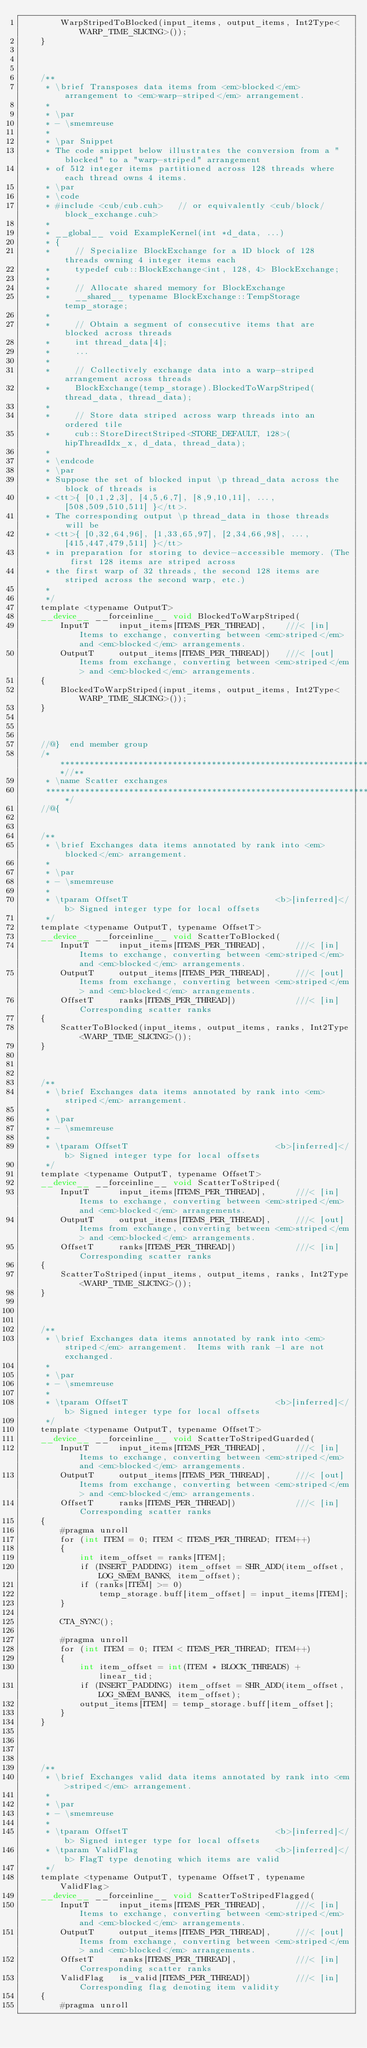Convert code to text. <code><loc_0><loc_0><loc_500><loc_500><_Cuda_>        WarpStripedToBlocked(input_items, output_items, Int2Type<WARP_TIME_SLICING>());
    }



    /**
     * \brief Transposes data items from <em>blocked</em> arrangement to <em>warp-striped</em> arrangement.
     *
     * \par
     * - \smemreuse
     *
     * \par Snippet
     * The code snippet below illustrates the conversion from a "blocked" to a "warp-striped" arrangement
     * of 512 integer items partitioned across 128 threads where each thread owns 4 items.
     * \par
     * \code
     * #include <cub/cub.cuh>   // or equivalently <cub/block/block_exchange.cuh>
     *
     * __global__ void ExampleKernel(int *d_data, ...)
     * {
     *     // Specialize BlockExchange for a 1D block of 128 threads owning 4 integer items each
     *     typedef cub::BlockExchange<int, 128, 4> BlockExchange;
     *
     *     // Allocate shared memory for BlockExchange
     *     __shared__ typename BlockExchange::TempStorage temp_storage;
     *
     *     // Obtain a segment of consecutive items that are blocked across threads
     *     int thread_data[4];
     *     ...
     *
     *     // Collectively exchange data into a warp-striped arrangement across threads
     *     BlockExchange(temp_storage).BlockedToWarpStriped(thread_data, thread_data);
     *
     *     // Store data striped across warp threads into an ordered tile
     *     cub::StoreDirectStriped<STORE_DEFAULT, 128>(hipThreadIdx_x, d_data, thread_data);
     *
     * \endcode
     * \par
     * Suppose the set of blocked input \p thread_data across the block of threads is
     * <tt>{ [0,1,2,3], [4,5,6,7], [8,9,10,11], ..., [508,509,510,511] }</tt>.
     * The corresponding output \p thread_data in those threads will be
     * <tt>{ [0,32,64,96], [1,33,65,97], [2,34,66,98], ..., [415,447,479,511] }</tt>
     * in preparation for storing to device-accessible memory. (The first 128 items are striped across
     * the first warp of 32 threads, the second 128 items are striped across the second warp, etc.)
     *
     */
    template <typename OutputT>
    __device__ __forceinline__ void BlockedToWarpStriped(
        InputT      input_items[ITEMS_PER_THREAD],    ///< [in] Items to exchange, converting between <em>striped</em> and <em>blocked</em> arrangements.
        OutputT     output_items[ITEMS_PER_THREAD])   ///< [out] Items from exchange, converting between <em>striped</em> and <em>blocked</em> arrangements.
    {
        BlockedToWarpStriped(input_items, output_items, Int2Type<WARP_TIME_SLICING>());
    }



    //@}  end member group
    /******************************************************************//**
     * \name Scatter exchanges
     *********************************************************************/
    //@{


    /**
     * \brief Exchanges data items annotated by rank into <em>blocked</em> arrangement.
     *
     * \par
     * - \smemreuse
     *
     * \tparam OffsetT                              <b>[inferred]</b> Signed integer type for local offsets
     */
    template <typename OutputT, typename OffsetT>
    __device__ __forceinline__ void ScatterToBlocked(
        InputT      input_items[ITEMS_PER_THREAD],      ///< [in] Items to exchange, converting between <em>striped</em> and <em>blocked</em> arrangements.
        OutputT     output_items[ITEMS_PER_THREAD],     ///< [out] Items from exchange, converting between <em>striped</em> and <em>blocked</em> arrangements.
        OffsetT     ranks[ITEMS_PER_THREAD])            ///< [in] Corresponding scatter ranks
    {
        ScatterToBlocked(input_items, output_items, ranks, Int2Type<WARP_TIME_SLICING>());
    }



    /**
     * \brief Exchanges data items annotated by rank into <em>striped</em> arrangement.
     *
     * \par
     * - \smemreuse
     *
     * \tparam OffsetT                              <b>[inferred]</b> Signed integer type for local offsets
     */
    template <typename OutputT, typename OffsetT>
    __device__ __forceinline__ void ScatterToStriped(
        InputT      input_items[ITEMS_PER_THREAD],      ///< [in] Items to exchange, converting between <em>striped</em> and <em>blocked</em> arrangements.
        OutputT     output_items[ITEMS_PER_THREAD],     ///< [out] Items from exchange, converting between <em>striped</em> and <em>blocked</em> arrangements.
        OffsetT     ranks[ITEMS_PER_THREAD])            ///< [in] Corresponding scatter ranks
    {
        ScatterToStriped(input_items, output_items, ranks, Int2Type<WARP_TIME_SLICING>());
    }



    /**
     * \brief Exchanges data items annotated by rank into <em>striped</em> arrangement.  Items with rank -1 are not exchanged.
     *
     * \par
     * - \smemreuse
     *
     * \tparam OffsetT                              <b>[inferred]</b> Signed integer type for local offsets
     */
    template <typename OutputT, typename OffsetT>
    __device__ __forceinline__ void ScatterToStripedGuarded(
        InputT      input_items[ITEMS_PER_THREAD],      ///< [in] Items to exchange, converting between <em>striped</em> and <em>blocked</em> arrangements.
        OutputT     output_items[ITEMS_PER_THREAD],     ///< [out] Items from exchange, converting between <em>striped</em> and <em>blocked</em> arrangements.
        OffsetT     ranks[ITEMS_PER_THREAD])            ///< [in] Corresponding scatter ranks
    {
        #pragma unroll
        for (int ITEM = 0; ITEM < ITEMS_PER_THREAD; ITEM++)
        {
            int item_offset = ranks[ITEM];
            if (INSERT_PADDING) item_offset = SHR_ADD(item_offset, LOG_SMEM_BANKS, item_offset);
            if (ranks[ITEM] >= 0)
                temp_storage.buff[item_offset] = input_items[ITEM];
        }

        CTA_SYNC();

        #pragma unroll
        for (int ITEM = 0; ITEM < ITEMS_PER_THREAD; ITEM++)
        {
            int item_offset = int(ITEM * BLOCK_THREADS) + linear_tid;
            if (INSERT_PADDING) item_offset = SHR_ADD(item_offset, LOG_SMEM_BANKS, item_offset);
            output_items[ITEM] = temp_storage.buff[item_offset];
        }
    }




    /**
     * \brief Exchanges valid data items annotated by rank into <em>striped</em> arrangement.
     *
     * \par
     * - \smemreuse
     *
     * \tparam OffsetT                              <b>[inferred]</b> Signed integer type for local offsets
     * \tparam ValidFlag                            <b>[inferred]</b> FlagT type denoting which items are valid
     */
    template <typename OutputT, typename OffsetT, typename ValidFlag>
    __device__ __forceinline__ void ScatterToStripedFlagged(
        InputT      input_items[ITEMS_PER_THREAD],      ///< [in] Items to exchange, converting between <em>striped</em> and <em>blocked</em> arrangements.
        OutputT     output_items[ITEMS_PER_THREAD],     ///< [out] Items from exchange, converting between <em>striped</em> and <em>blocked</em> arrangements.
        OffsetT     ranks[ITEMS_PER_THREAD],            ///< [in] Corresponding scatter ranks
        ValidFlag   is_valid[ITEMS_PER_THREAD])         ///< [in] Corresponding flag denoting item validity
    {
        #pragma unroll</code> 